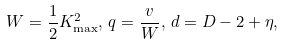Convert formula to latex. <formula><loc_0><loc_0><loc_500><loc_500>W = \frac { 1 } { 2 } K _ { \max } ^ { 2 } , \, q = \frac { v } { W } , \, d = D - 2 + \eta ,</formula> 